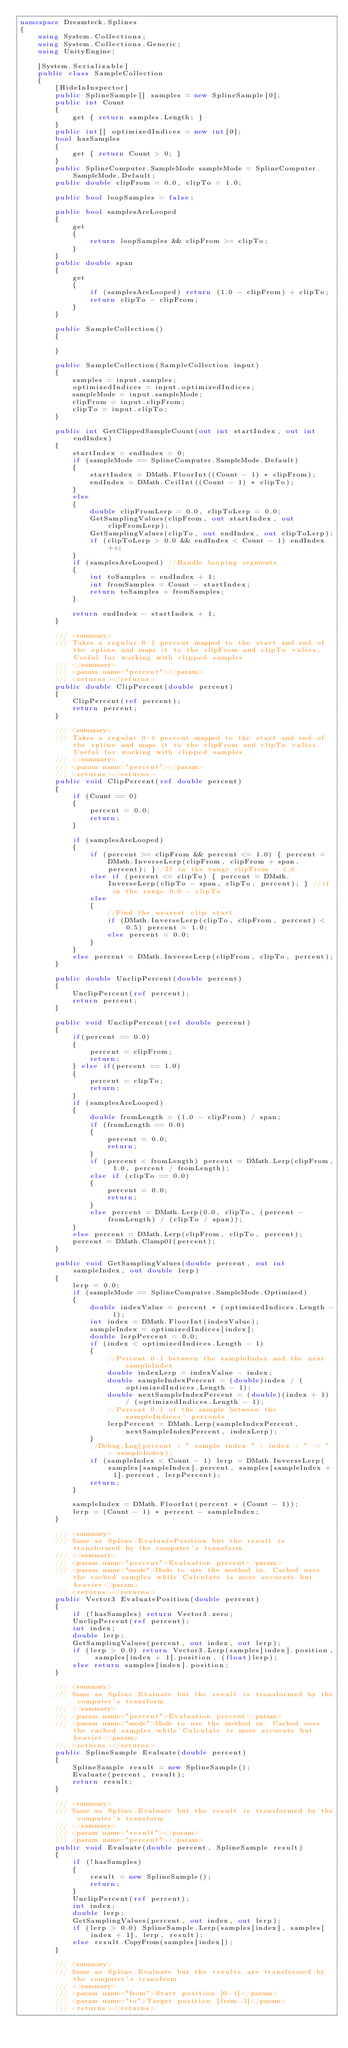Convert code to text. <code><loc_0><loc_0><loc_500><loc_500><_C#_>namespace Dreamteck.Splines
{
    using System.Collections;
    using System.Collections.Generic;
    using UnityEngine;

    [System.Serializable]
    public class SampleCollection
    {
        [HideInInspector]
        public SplineSample[] samples = new SplineSample[0];
        public int Count
        {
            get { return samples.Length; }
        }
        public int[] optimizedIndices = new int[0];
        bool hasSamples
        {
            get { return Count > 0; }
        }
        public SplineComputer.SampleMode sampleMode = SplineComputer.SampleMode.Default;
        public double clipFrom = 0.0, clipTo = 1.0;

        public bool loopSamples = false;

        public bool samplesAreLooped
        {
            get
            {
                return loopSamples && clipFrom >= clipTo;
            }
        }
        public double span
        {
            get
            {
                if (samplesAreLooped) return (1.0 - clipFrom) + clipTo;
                return clipTo - clipFrom;
            }
        }

        public SampleCollection()
        {

        }

        public SampleCollection(SampleCollection input)
        {
            samples = input.samples;
            optimizedIndices = input.optimizedIndices;
            sampleMode = input.sampleMode;
            clipFrom = input.clipFrom;
            clipTo = input.clipTo;
        }

        public int GetClippedSampleCount(out int startIndex, out int endIndex)
        {
            startIndex = endIndex = 0;
            if (sampleMode == SplineComputer.SampleMode.Default)
            {
                startIndex = DMath.FloorInt((Count - 1) * clipFrom);
                endIndex = DMath.CeilInt((Count - 1) * clipTo);
            }
            else
            {
                double clipFromLerp = 0.0, clipToLerp = 0.0;
                GetSamplingValues(clipFrom, out startIndex, out clipFromLerp);
                GetSamplingValues(clipTo, out endIndex, out clipToLerp);
                if (clipToLerp > 0.0 && endIndex < Count - 1) endIndex++;
            }
            if (samplesAreLooped) //Handle looping segments
            {
                int toSamples = endIndex + 1;
                int fromSamples = Count - startIndex;
                return toSamples + fromSamples;
            }

            return endIndex - startIndex + 1;
        }

        /// <summary>
        /// Takes a regular 0-1 percent mapped to the start and end of the spline and maps it to the clipFrom and clipTo valies. Useful for working with clipped samples
        /// </summary>
        /// <param name="percent"></param>
        /// <returns></returns>
        public double ClipPercent(double percent)
        {
            ClipPercent(ref percent);
            return percent;
        }

        /// <summary>
        /// Takes a regular 0-1 percent mapped to the start and end of the spline and maps it to the clipFrom and clipTo valies. Useful for working with clipped samples
        /// </summary>
        /// <param name="percent"></param>
        /// <returns></returns>
        public void ClipPercent(ref double percent)
        {
            if (Count == 0)
            {
                percent = 0.0;
                return;
            }

            if (samplesAreLooped)
            {
                if (percent >= clipFrom && percent <= 1.0) { percent = DMath.InverseLerp(clipFrom, clipFrom + span, percent); }//If in the range clipFrom - 1.0
                else if (percent <= clipTo) { percent = DMath.InverseLerp(clipTo - span, clipTo, percent); } //if in the range 0.0 - clipTo
                else
                {
                    //Find the nearest clip start
                    if (DMath.InverseLerp(clipTo, clipFrom, percent) < 0.5) percent = 1.0;
                    else percent = 0.0;
                }
            }
            else percent = DMath.InverseLerp(clipFrom, clipTo, percent);
        }

        public double UnclipPercent(double percent)
        {
            UnclipPercent(ref percent);
            return percent;
        }

        public void UnclipPercent(ref double percent)
        {
            if(percent == 0.0)
            {
                percent = clipFrom;
                return;
            } else if(percent == 1.0)
            {
                percent = clipTo;
                return;
            }
            if (samplesAreLooped)
            {
                double fromLength = (1.0 - clipFrom) / span;
                if (fromLength == 0.0)
                {
                    percent = 0.0;
                    return;
                }
                if (percent < fromLength) percent = DMath.Lerp(clipFrom, 1.0, percent / fromLength);
                else if (clipTo == 0.0)
                {
                    percent = 0.0;
                    return;
                }
                else percent = DMath.Lerp(0.0, clipTo, (percent - fromLength) / (clipTo / span));
            }
            else percent = DMath.Lerp(clipFrom, clipTo, percent);
            percent = DMath.Clamp01(percent);
        }

        public void GetSamplingValues(double percent, out int sampleIndex, out double lerp)
        {
            lerp = 0.0;
            if (sampleMode == SplineComputer.SampleMode.Optimized)
            {
                double indexValue = percent * (optimizedIndices.Length - 1);
                int index = DMath.FloorInt(indexValue);
                sampleIndex = optimizedIndices[index];
                double lerpPercent = 0.0;
                if (index < optimizedIndices.Length - 1)
                {
                    //Percent 0-1 between the sampleIndex and the next sampleIndex
                    double indexLerp = indexValue - index;
                    double sampleIndexPercent = (double)index / (optimizedIndices.Length - 1);
                    double nextSampleIndexPercent = (double)(index + 1) / (optimizedIndices.Length - 1);
                    //Percent 0-1 of the sample between the sampleIndices' percents
                    lerpPercent = DMath.Lerp(sampleIndexPercent, nextSampleIndexPercent, indexLerp);
                }
                //Debug.Log(percent + " sample index " + index + " -> " + sampleIndex);
                if (sampleIndex < Count - 1) lerp = DMath.InverseLerp(samples[sampleIndex].percent, samples[sampleIndex + 1].percent, lerpPercent);
                return;
            }

            sampleIndex = DMath.FloorInt(percent * (Count - 1));
            lerp = (Count - 1) * percent - sampleIndex;
        }

        /// <summary>
        /// Same as Spline.EvaluatePosition but the result is transformed by the computer's transform
        /// </summary>
        /// <param name="percent">Evaluation percent</param>
        /// <param name="mode">Mode to use the method in. Cached uses the cached samples while Calculate is more accurate but heavier</param>
        /// <returns></returns>
        public Vector3 EvaluatePosition(double percent)
        {
            if (!hasSamples) return Vector3.zero;
            UnclipPercent(ref percent);
            int index;
            double lerp;
            GetSamplingValues(percent, out index, out lerp);
            if (lerp > 0.0) return Vector3.Lerp(samples[index].position, samples[index + 1].position, (float)lerp);
            else return samples[index].position;
        }

        /// <summary>
        /// Same as Spline.Evaluate but the result is transformed by the computer's transform
        /// </summary>
        /// <param name="percent">Evaluation percent</param>
        /// <param name="mode">Mode to use the method in. Cached uses the cached samples while Calculate is more accurate but heavier</param>
        /// <returns></returns>
        public SplineSample Evaluate(double percent)
        {
            SplineSample result = new SplineSample();
            Evaluate(percent, result);
            return result;
        }

        /// <summary>
        /// Same as Spline.Evaluate but the result is transformed by the computer's transform
        /// </summary>
        /// <param name="result"></param>
        /// <param name="percent"></param>
        public void Evaluate(double percent, SplineSample result)
        {
            if (!hasSamples)
            {
                result = new SplineSample();
                return;
            }
            UnclipPercent(ref percent);
            int index;
            double lerp;
            GetSamplingValues(percent, out index, out lerp);
            if (lerp > 0.0) SplineSample.Lerp(samples[index], samples[index + 1], lerp, result);
            else result.CopyFrom(samples[index]);
        }

        /// <summary>
        /// Same as Spline.Evaluate but the results are transformed by the computer's transform
        /// </summary>
        /// <param name="from">Start position [0-1]</param>
        /// <param name="to">Target position [from-1]</param>
        /// <returns></returns></code> 